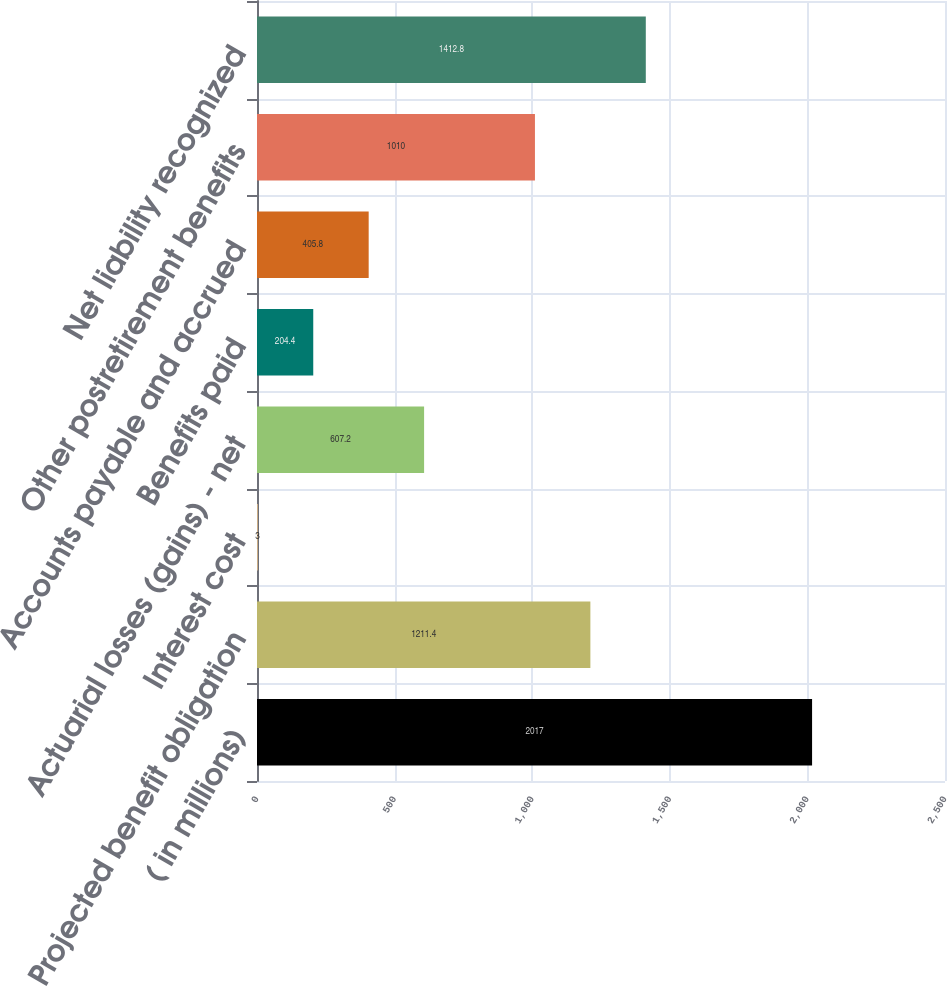Convert chart. <chart><loc_0><loc_0><loc_500><loc_500><bar_chart><fcel>( in millions)<fcel>Projected benefit obligation<fcel>Interest cost<fcel>Actuarial losses (gains) - net<fcel>Benefits paid<fcel>Accounts payable and accrued<fcel>Other postretirement benefits<fcel>Net liability recognized<nl><fcel>2017<fcel>1211.4<fcel>3<fcel>607.2<fcel>204.4<fcel>405.8<fcel>1010<fcel>1412.8<nl></chart> 